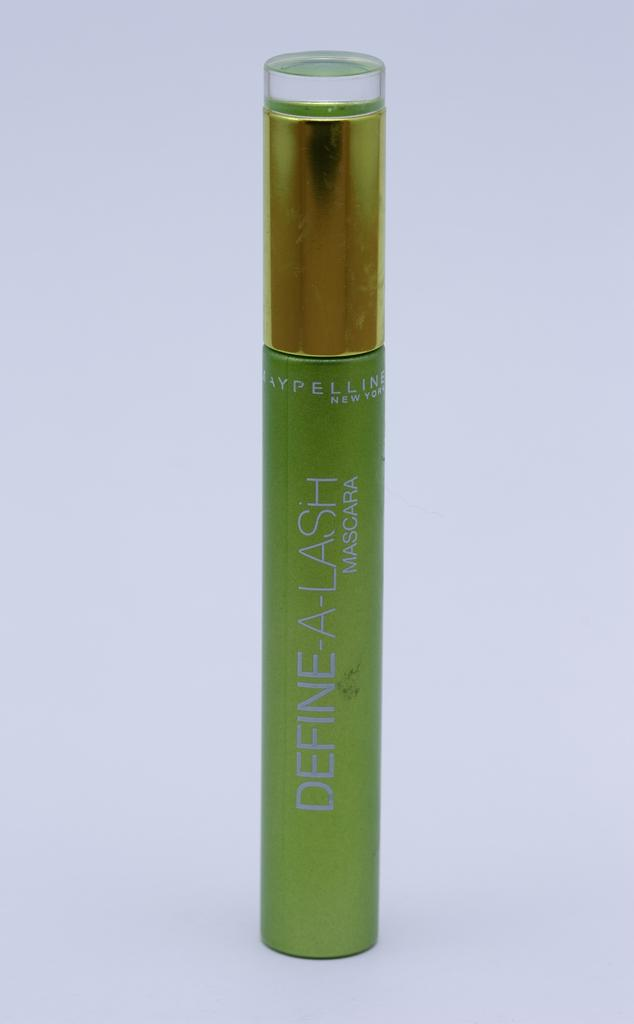<image>
Share a concise interpretation of the image provided. A green container says define a lash mascara. 